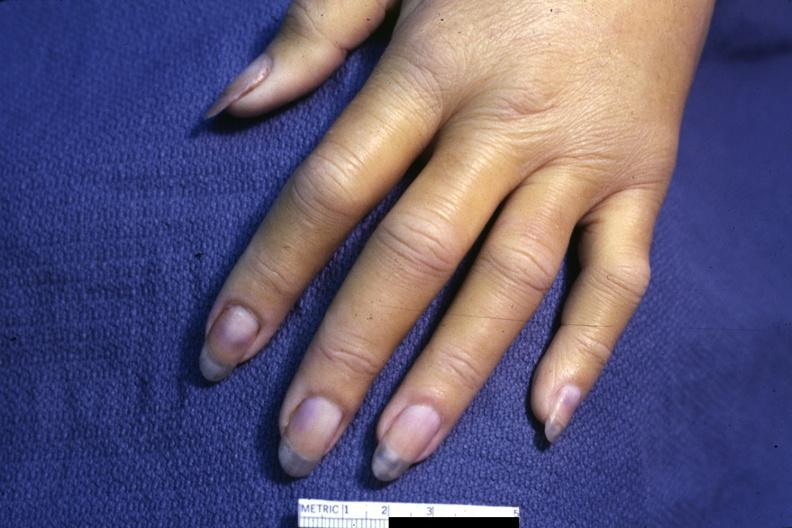how does case of dic not bad photo require dark room to see subtle phalangeal cyanosis?
Answer the question using a single word or phrase. Distal 